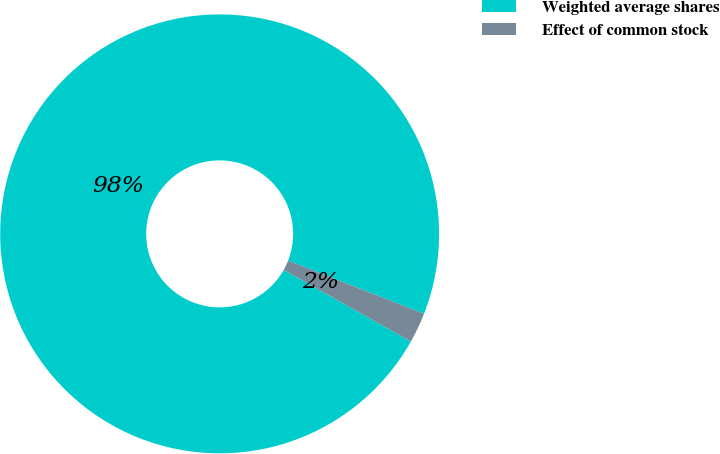Convert chart to OTSL. <chart><loc_0><loc_0><loc_500><loc_500><pie_chart><fcel>Weighted average shares<fcel>Effect of common stock<nl><fcel>97.77%<fcel>2.23%<nl></chart> 